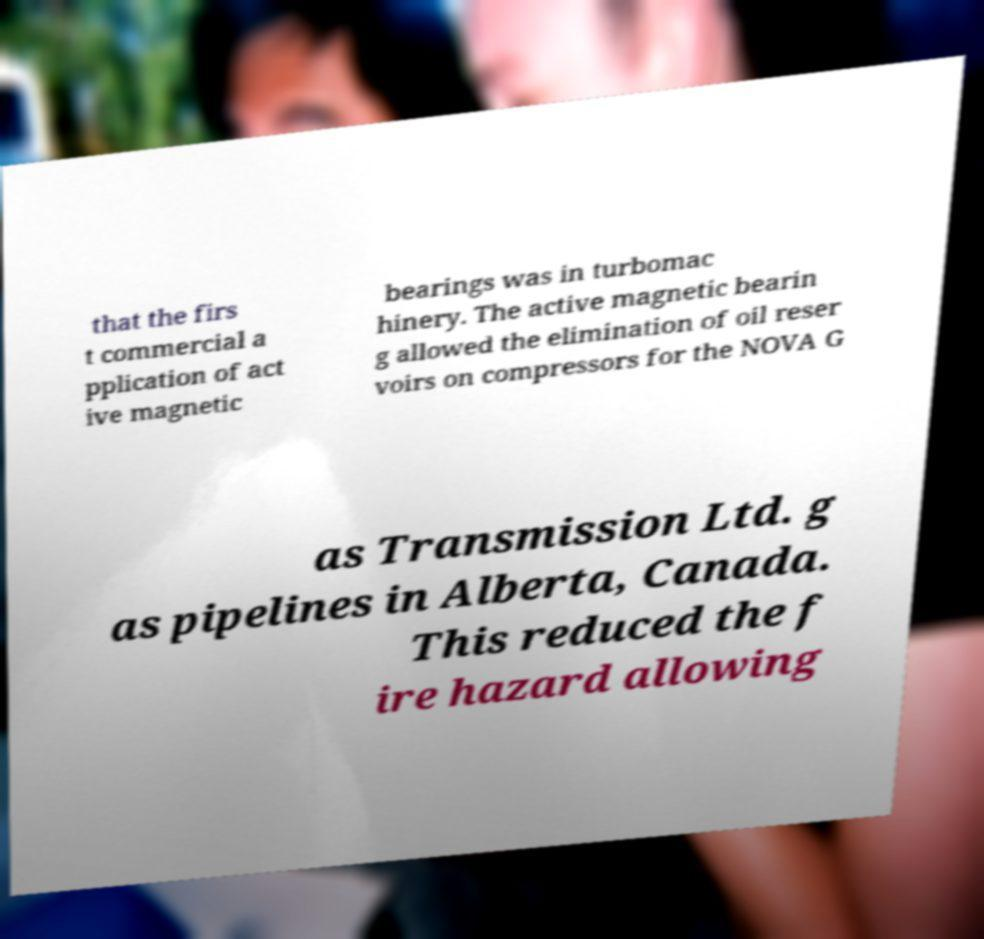What messages or text are displayed in this image? I need them in a readable, typed format. that the firs t commercial a pplication of act ive magnetic bearings was in turbomac hinery. The active magnetic bearin g allowed the elimination of oil reser voirs on compressors for the NOVA G as Transmission Ltd. g as pipelines in Alberta, Canada. This reduced the f ire hazard allowing 